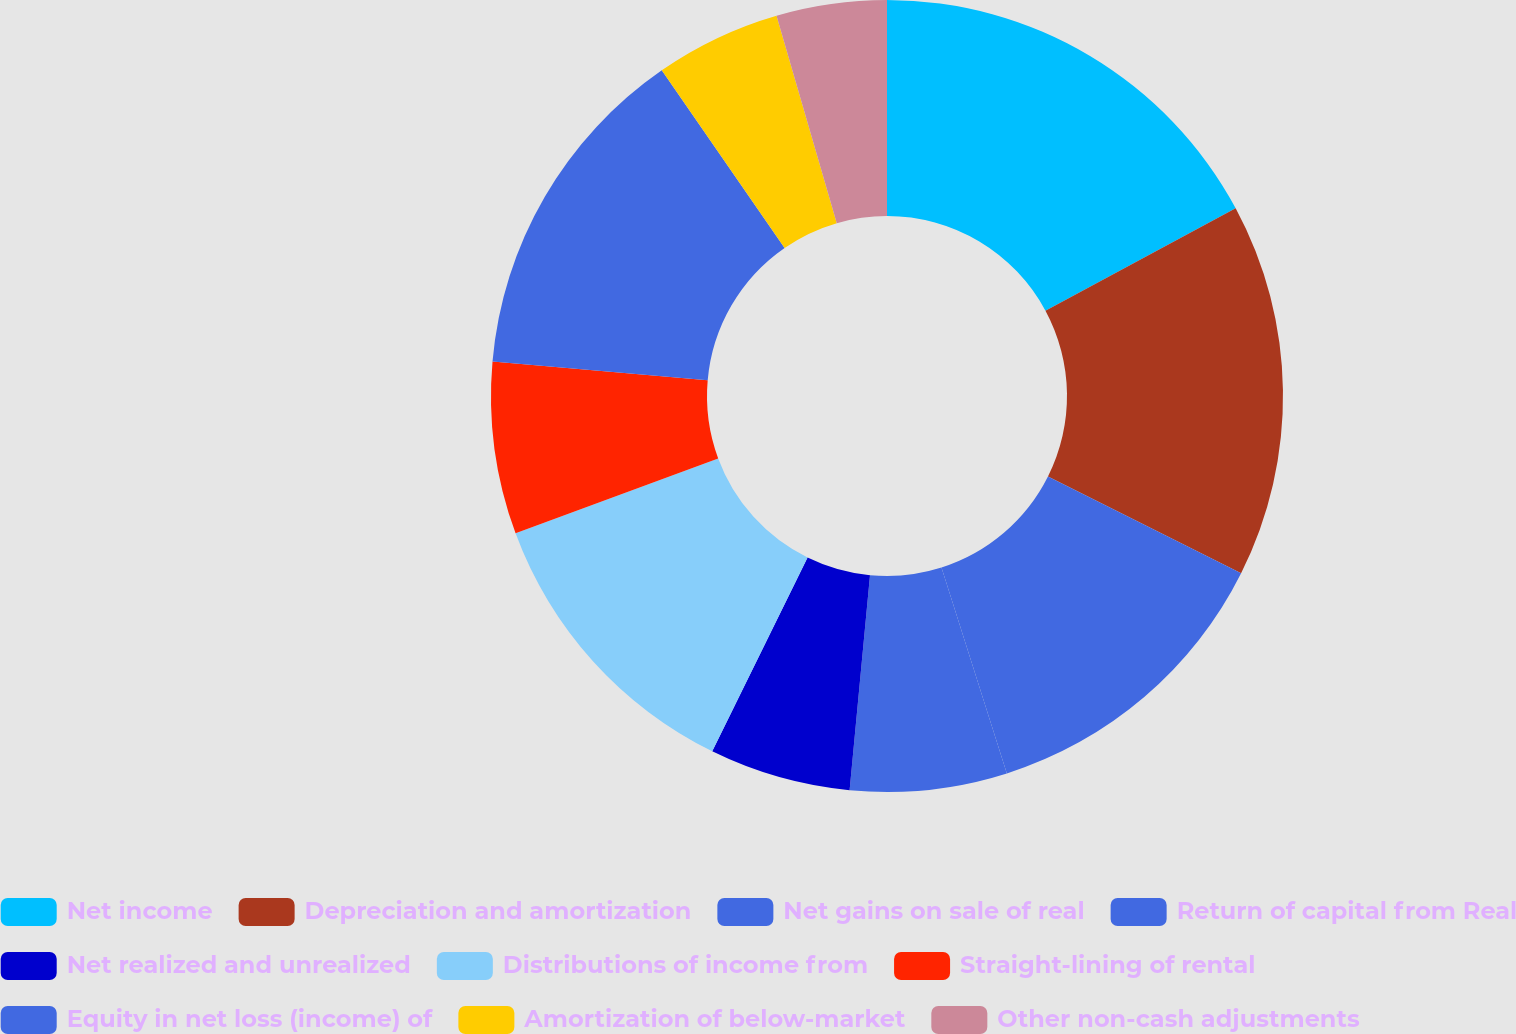<chart> <loc_0><loc_0><loc_500><loc_500><pie_chart><fcel>Net income<fcel>Depreciation and amortization<fcel>Net gains on sale of real<fcel>Return of capital from Real<fcel>Net realized and unrealized<fcel>Distributions of income from<fcel>Straight-lining of rental<fcel>Equity in net loss (income) of<fcel>Amortization of below-market<fcel>Other non-cash adjustments<nl><fcel>17.14%<fcel>15.25%<fcel>12.72%<fcel>6.4%<fcel>5.77%<fcel>12.09%<fcel>7.03%<fcel>13.98%<fcel>5.13%<fcel>4.5%<nl></chart> 